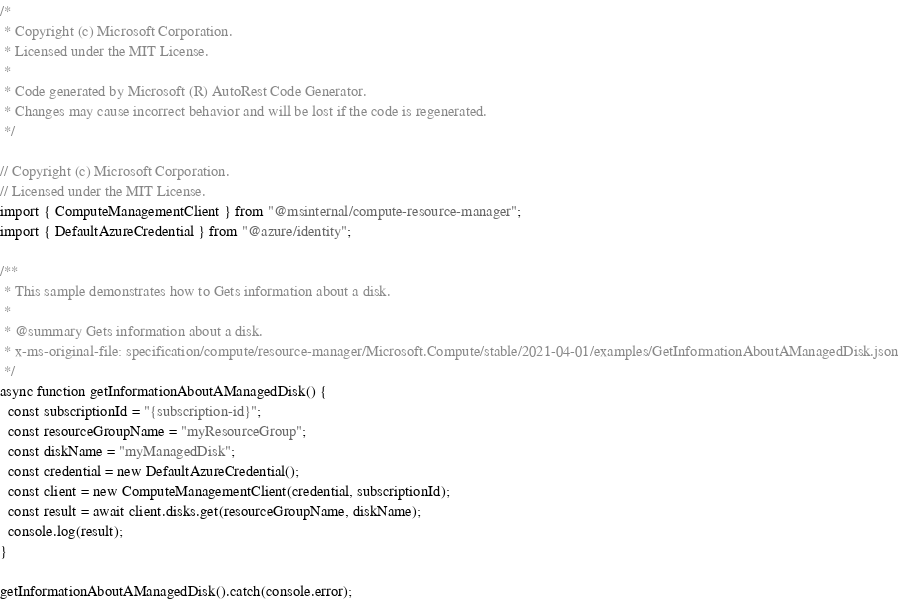<code> <loc_0><loc_0><loc_500><loc_500><_TypeScript_>/*
 * Copyright (c) Microsoft Corporation.
 * Licensed under the MIT License.
 *
 * Code generated by Microsoft (R) AutoRest Code Generator.
 * Changes may cause incorrect behavior and will be lost if the code is regenerated.
 */

// Copyright (c) Microsoft Corporation.
// Licensed under the MIT License.
import { ComputeManagementClient } from "@msinternal/compute-resource-manager";
import { DefaultAzureCredential } from "@azure/identity";

/**
 * This sample demonstrates how to Gets information about a disk.
 *
 * @summary Gets information about a disk.
 * x-ms-original-file: specification/compute/resource-manager/Microsoft.Compute/stable/2021-04-01/examples/GetInformationAboutAManagedDisk.json
 */
async function getInformationAboutAManagedDisk() {
  const subscriptionId = "{subscription-id}";
  const resourceGroupName = "myResourceGroup";
  const diskName = "myManagedDisk";
  const credential = new DefaultAzureCredential();
  const client = new ComputeManagementClient(credential, subscriptionId);
  const result = await client.disks.get(resourceGroupName, diskName);
  console.log(result);
}

getInformationAboutAManagedDisk().catch(console.error);
</code> 